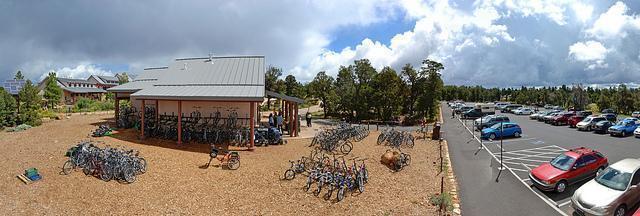What kind of facility can be found nearby?
Choose the correct response and explain in the format: 'Answer: answer
Rationale: rationale.'
Options: Fish pond, bike trail, hiking trail, picnic area. Answer: bike trail.
Rationale: There are many bikes there to ride around on trails and biking paths. 